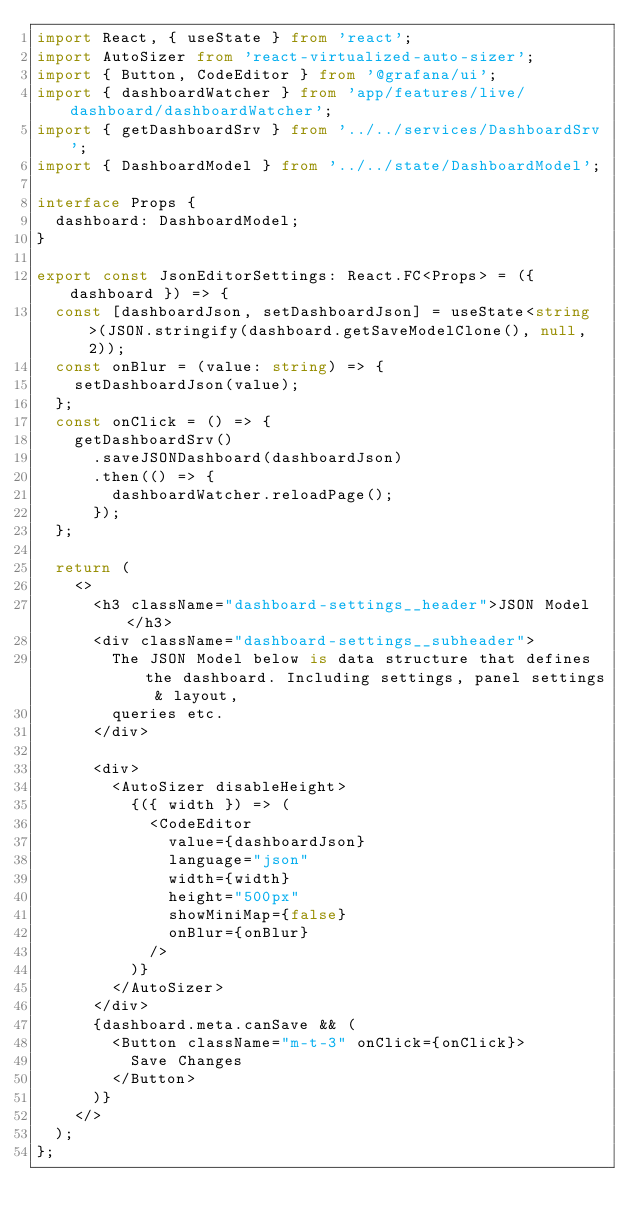<code> <loc_0><loc_0><loc_500><loc_500><_TypeScript_>import React, { useState } from 'react';
import AutoSizer from 'react-virtualized-auto-sizer';
import { Button, CodeEditor } from '@grafana/ui';
import { dashboardWatcher } from 'app/features/live/dashboard/dashboardWatcher';
import { getDashboardSrv } from '../../services/DashboardSrv';
import { DashboardModel } from '../../state/DashboardModel';

interface Props {
  dashboard: DashboardModel;
}

export const JsonEditorSettings: React.FC<Props> = ({ dashboard }) => {
  const [dashboardJson, setDashboardJson] = useState<string>(JSON.stringify(dashboard.getSaveModelClone(), null, 2));
  const onBlur = (value: string) => {
    setDashboardJson(value);
  };
  const onClick = () => {
    getDashboardSrv()
      .saveJSONDashboard(dashboardJson)
      .then(() => {
        dashboardWatcher.reloadPage();
      });
  };

  return (
    <>
      <h3 className="dashboard-settings__header">JSON Model</h3>
      <div className="dashboard-settings__subheader">
        The JSON Model below is data structure that defines the dashboard. Including settings, panel settings & layout,
        queries etc.
      </div>

      <div>
        <AutoSizer disableHeight>
          {({ width }) => (
            <CodeEditor
              value={dashboardJson}
              language="json"
              width={width}
              height="500px"
              showMiniMap={false}
              onBlur={onBlur}
            />
          )}
        </AutoSizer>
      </div>
      {dashboard.meta.canSave && (
        <Button className="m-t-3" onClick={onClick}>
          Save Changes
        </Button>
      )}
    </>
  );
};
</code> 